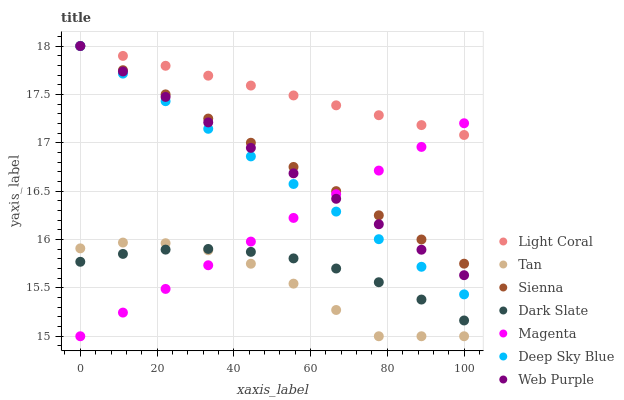Does Tan have the minimum area under the curve?
Answer yes or no. Yes. Does Light Coral have the maximum area under the curve?
Answer yes or no. Yes. Does Dark Slate have the minimum area under the curve?
Answer yes or no. No. Does Dark Slate have the maximum area under the curve?
Answer yes or no. No. Is Light Coral the smoothest?
Answer yes or no. Yes. Is Tan the roughest?
Answer yes or no. Yes. Is Dark Slate the smoothest?
Answer yes or no. No. Is Dark Slate the roughest?
Answer yes or no. No. Does Tan have the lowest value?
Answer yes or no. Yes. Does Dark Slate have the lowest value?
Answer yes or no. No. Does Deep Sky Blue have the highest value?
Answer yes or no. Yes. Does Dark Slate have the highest value?
Answer yes or no. No. Is Dark Slate less than Light Coral?
Answer yes or no. Yes. Is Deep Sky Blue greater than Dark Slate?
Answer yes or no. Yes. Does Deep Sky Blue intersect Light Coral?
Answer yes or no. Yes. Is Deep Sky Blue less than Light Coral?
Answer yes or no. No. Is Deep Sky Blue greater than Light Coral?
Answer yes or no. No. Does Dark Slate intersect Light Coral?
Answer yes or no. No. 